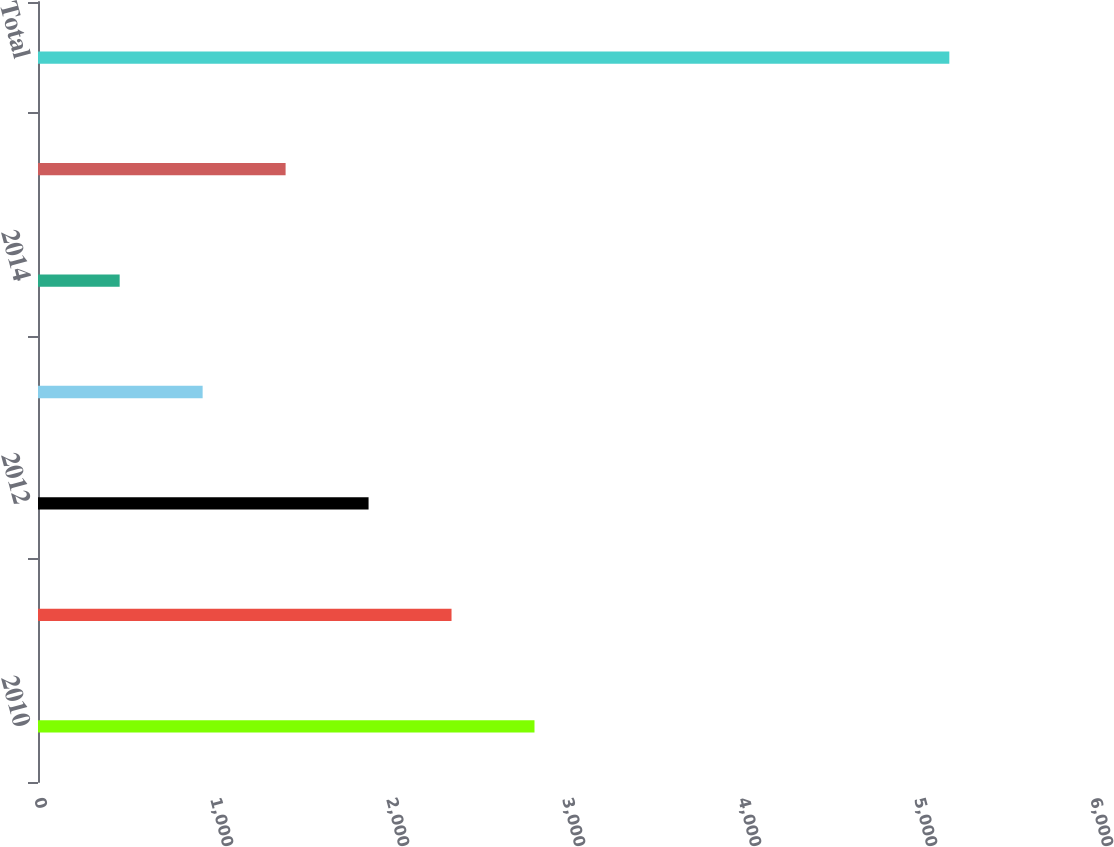Convert chart to OTSL. <chart><loc_0><loc_0><loc_500><loc_500><bar_chart><fcel>2010<fcel>2011<fcel>2012<fcel>2013<fcel>2014<fcel>Thereafter<fcel>Total<nl><fcel>2821<fcel>2349.6<fcel>1878.2<fcel>935.4<fcel>464<fcel>1406.8<fcel>5178<nl></chart> 